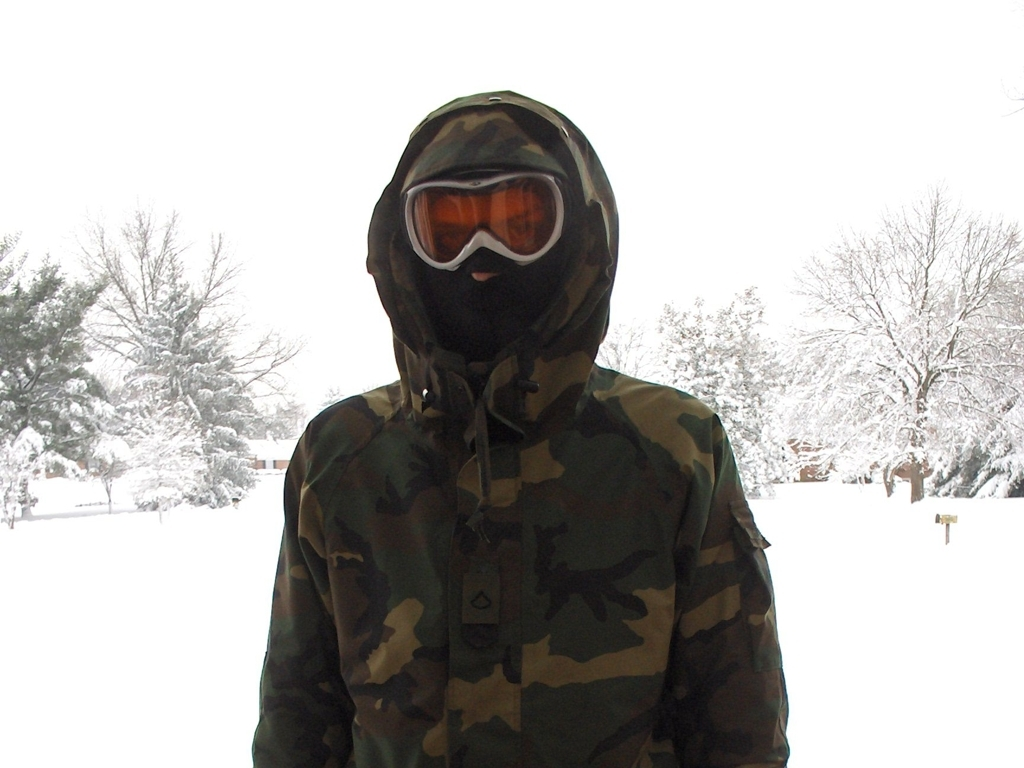Can you describe the environment and conditions portrayed in the image? The image depicts a wintry scene with thick snow covering the ground and trees. It appears to be a residential area judging by the distant houses. The overcast sky suggests a recent or ongoing snowfall, creating a tranquil and muted atmosphere. 